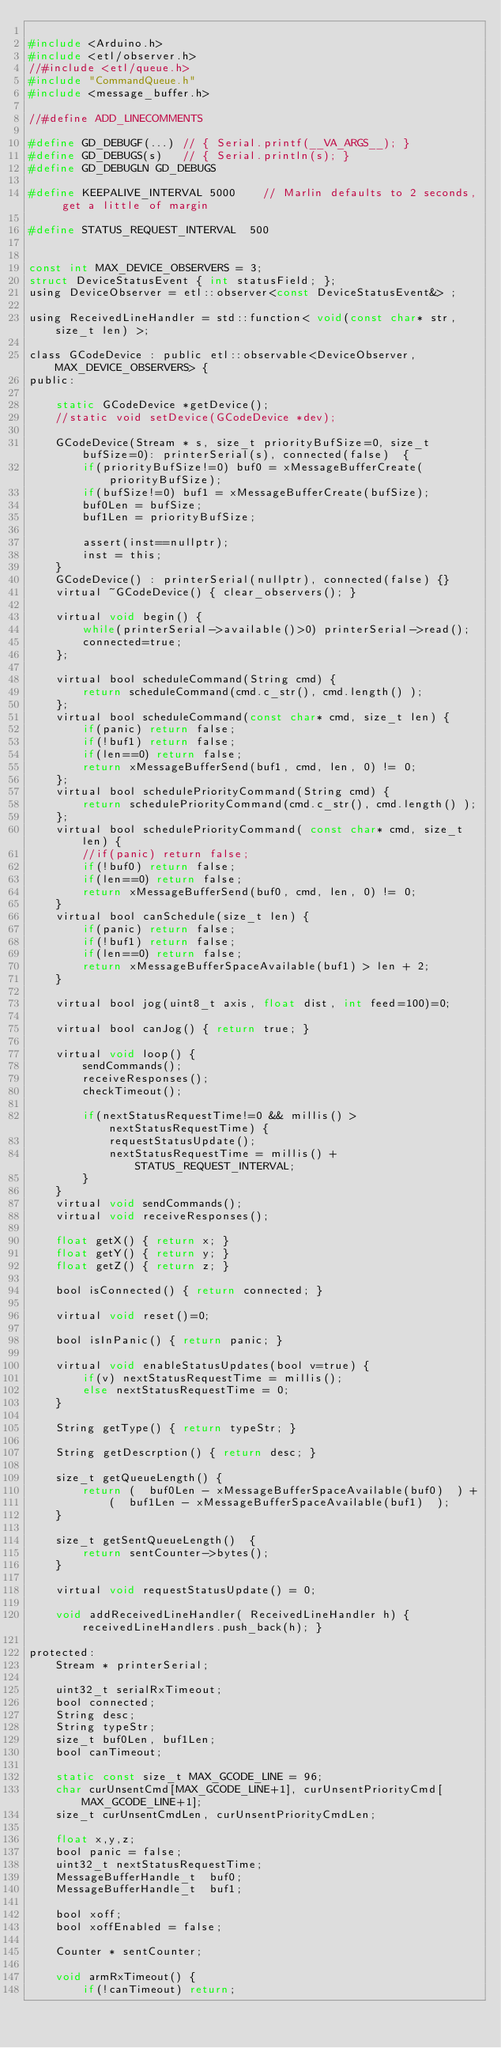Convert code to text. <code><loc_0><loc_0><loc_500><loc_500><_C_>
#include <Arduino.h>
#include <etl/observer.h>
//#include <etl/queue.h>
#include "CommandQueue.h"
#include <message_buffer.h>

//#define ADD_LINECOMMENTS

#define GD_DEBUGF(...) // { Serial.printf(__VA_ARGS__); }
#define GD_DEBUGS(s)   // { Serial.println(s); }
#define GD_DEBUGLN GD_DEBUGS

#define KEEPALIVE_INTERVAL 5000    // Marlin defaults to 2 seconds, get a little of margin

#define STATUS_REQUEST_INTERVAL  500


const int MAX_DEVICE_OBSERVERS = 3;
struct DeviceStatusEvent { int statusField; };
using DeviceObserver = etl::observer<const DeviceStatusEvent&> ;

using ReceivedLineHandler = std::function< void(const char* str, size_t len) >;

class GCodeDevice : public etl::observable<DeviceObserver, MAX_DEVICE_OBSERVERS> {
public:

    static GCodeDevice *getDevice();
    //static void setDevice(GCodeDevice *dev);

    GCodeDevice(Stream * s, size_t priorityBufSize=0, size_t bufSize=0): printerSerial(s), connected(false)  {
        if(priorityBufSize!=0) buf0 = xMessageBufferCreate(priorityBufSize);
        if(bufSize!=0) buf1 = xMessageBufferCreate(bufSize);
        buf0Len = bufSize;
        buf1Len = priorityBufSize;

        assert(inst==nullptr);
        inst = this;
    }
    GCodeDevice() : printerSerial(nullptr), connected(false) {}
    virtual ~GCodeDevice() { clear_observers(); }

    virtual void begin() { 
        while(printerSerial->available()>0) printerSerial->read(); 
        connected=true; 
    };

    virtual bool scheduleCommand(String cmd) {
        return scheduleCommand(cmd.c_str(), cmd.length() );
    };
    virtual bool scheduleCommand(const char* cmd, size_t len) {
        if(panic) return false;
        if(!buf1) return false;
        if(len==0) return false;
        return xMessageBufferSend(buf1, cmd, len, 0) != 0;
    };
    virtual bool schedulePriorityCommand(String cmd) { 
        return schedulePriorityCommand(cmd.c_str(), cmd.length() );
    };
    virtual bool schedulePriorityCommand( const char* cmd, size_t len) {
        //if(panic) return false;
        if(!buf0) return false;
        if(len==0) return false;
        return xMessageBufferSend(buf0, cmd, len, 0) != 0;
    }
    virtual bool canSchedule(size_t len) { 
        if(panic) return false;
        if(!buf1) return false; 
        if(len==0) return false;
        return xMessageBufferSpaceAvailable(buf1) > len + 2; 
    }

    virtual bool jog(uint8_t axis, float dist, int feed=100)=0;

    virtual bool canJog() { return true; }

    virtual void loop() {
        sendCommands();
        receiveResponses();
        checkTimeout();

        if(nextStatusRequestTime!=0 && millis() > nextStatusRequestTime) {
            requestStatusUpdate();
            nextStatusRequestTime = millis() + STATUS_REQUEST_INTERVAL;
        }
    }
    virtual void sendCommands();
    virtual void receiveResponses();

    float getX() { return x; }
    float getY() { return y; }
    float getZ() { return z; }

    bool isConnected() { return connected; }

    virtual void reset()=0;

    bool isInPanic() { return panic; }

    virtual void enableStatusUpdates(bool v=true) {
        if(v) nextStatusRequestTime = millis();
        else nextStatusRequestTime = 0;
    }

    String getType() { return typeStr; }

    String getDescrption() { return desc; }

    size_t getQueueLength() {  
        return (  buf0Len - xMessageBufferSpaceAvailable(buf0)  ) + 
            (  buf1Len - xMessageBufferSpaceAvailable(buf1)  ); 
    }

    size_t getSentQueueLength()  {
        return sentCounter->bytes();
    }

    virtual void requestStatusUpdate() = 0;

    void addReceivedLineHandler( ReceivedLineHandler h) { receivedLineHandlers.push_back(h); }

protected:
    Stream * printerSerial;

    uint32_t serialRxTimeout;
    bool connected;
    String desc;
    String typeStr;
    size_t buf0Len, buf1Len;
    bool canTimeout;

    static const size_t MAX_GCODE_LINE = 96;
    char curUnsentCmd[MAX_GCODE_LINE+1], curUnsentPriorityCmd[MAX_GCODE_LINE+1];
    size_t curUnsentCmdLen, curUnsentPriorityCmdLen;

    float x,y,z;
    bool panic = false;
    uint32_t nextStatusRequestTime;
    MessageBufferHandle_t  buf0;
    MessageBufferHandle_t  buf1;

    bool xoff;
    bool xoffEnabled = false;

    Counter * sentCounter;

    void armRxTimeout() {
        if(!canTimeout) return;</code> 